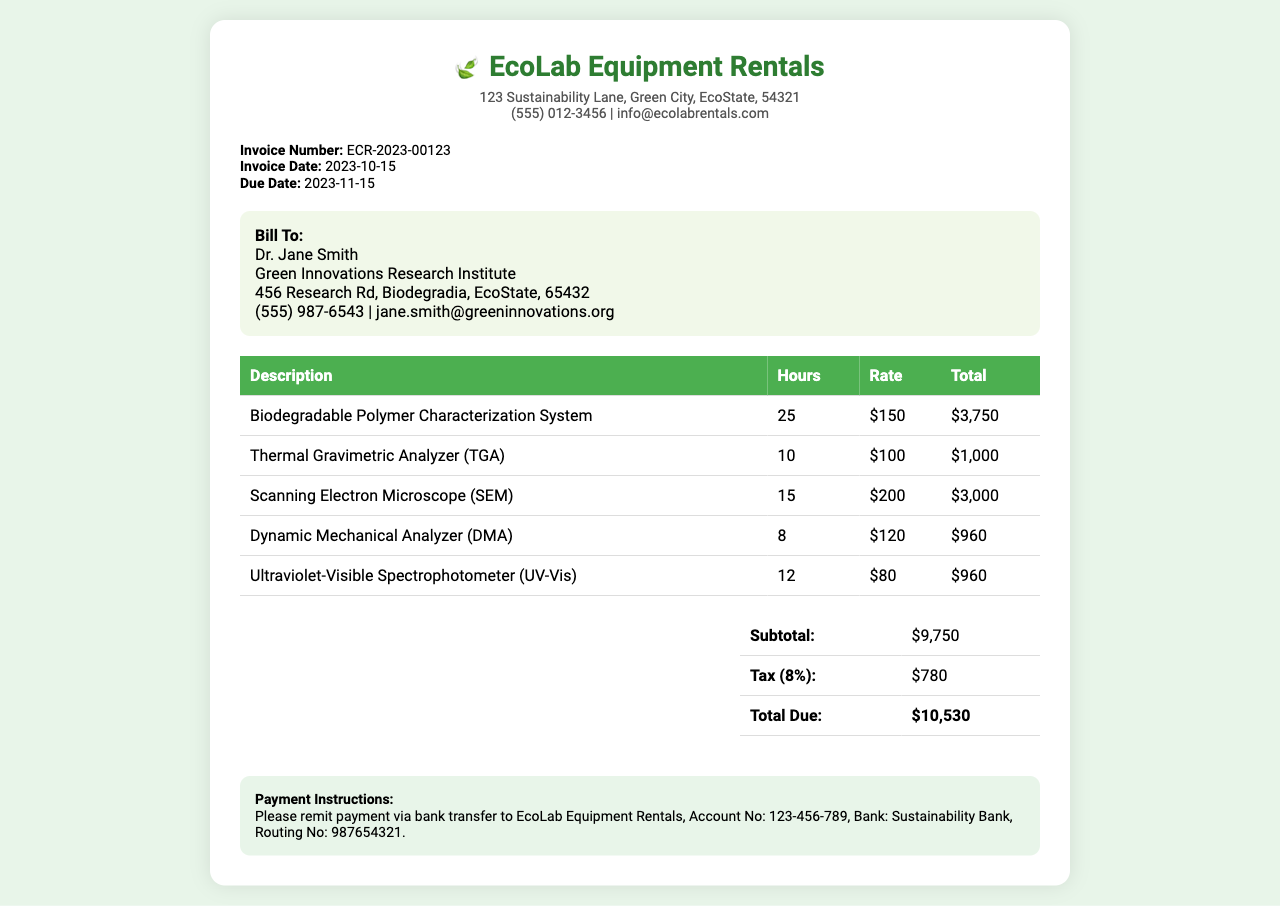What is the invoice number? The invoice number is specified in the invoice details section and is used for reference to this particular invoice.
Answer: ECR-2023-00123 Who is the billed party? The billed party is indicated in the bill to section, listing the name and organization receiving the invoice.
Answer: Dr. Jane Smith What is the total due amount? The total due is calculated as the subtotal plus tax and is stated at the end of the summary table.
Answer: $10,530 How many hours was the Scanning Electron Microscope rented? The number of hours for each piece of equipment is detailed in the itemized list of equipment and usage.
Answer: 15 What is the rate for the Biodegradable Polymer Characterization System? The rate for this equipment is shown in the rental rates listed next to the corresponding description in the table.
Answer: $150 What is the subtotal before tax? The subtotal is the total of all equipment rental charges before taxes and is listed in the summary section.
Answer: $9,750 When is the payment due? The due date for payment is provided in the invoice details and is important for timely payment.
Answer: 2023-11-15 What percentage is the tax applied? The tax percentage is explicitly mentioned in the summary section of the invoice.
Answer: 8% What type of document is this? The structure and content of the document indicate it is a billing statement for services provided, commonly known as an invoice.
Answer: Invoice 